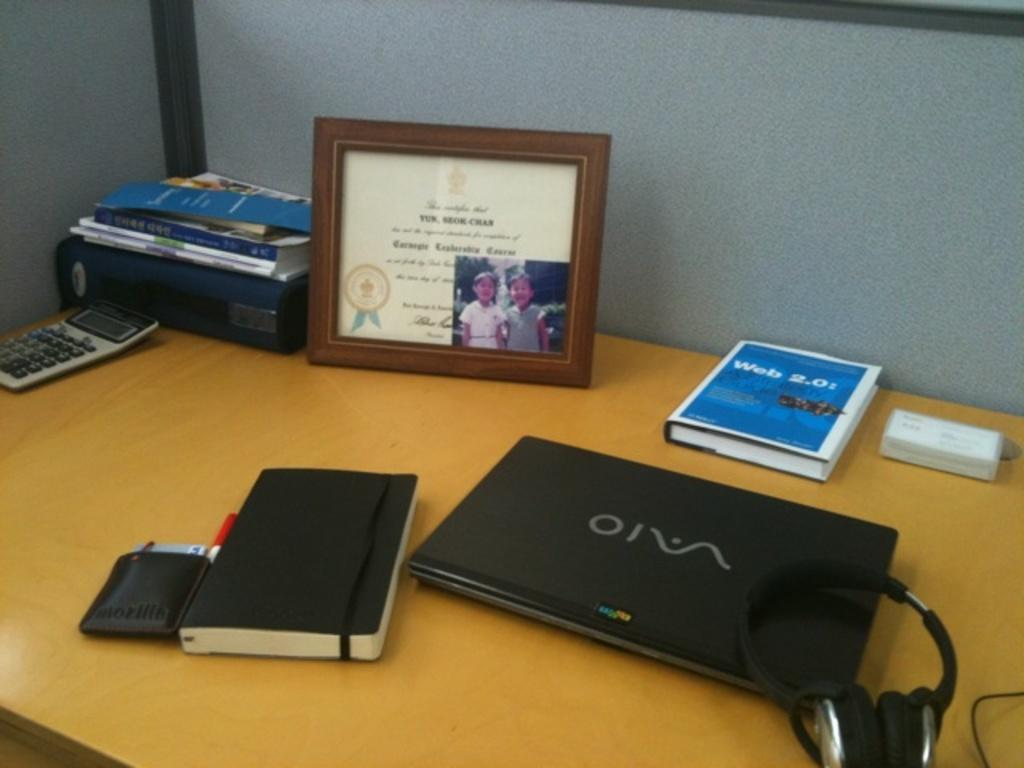<image>
Offer a succinct explanation of the picture presented. A book titled Web 2.0 sits on a desk behind a laptop. 